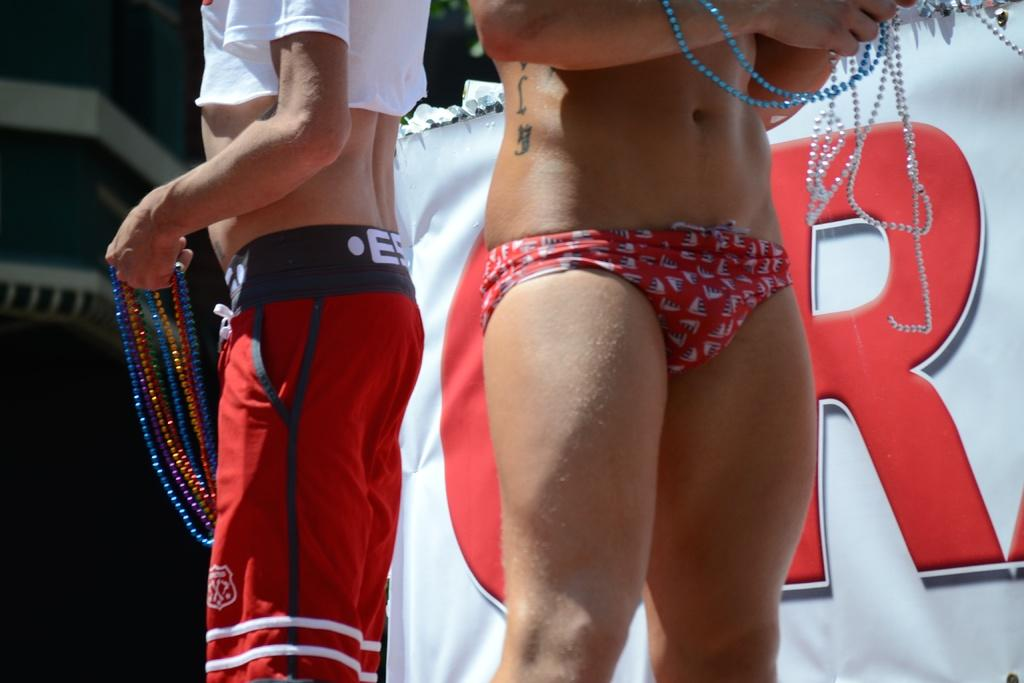Provide a one-sentence caption for the provided image. Two men in bathing suits hold bead necklaces. 